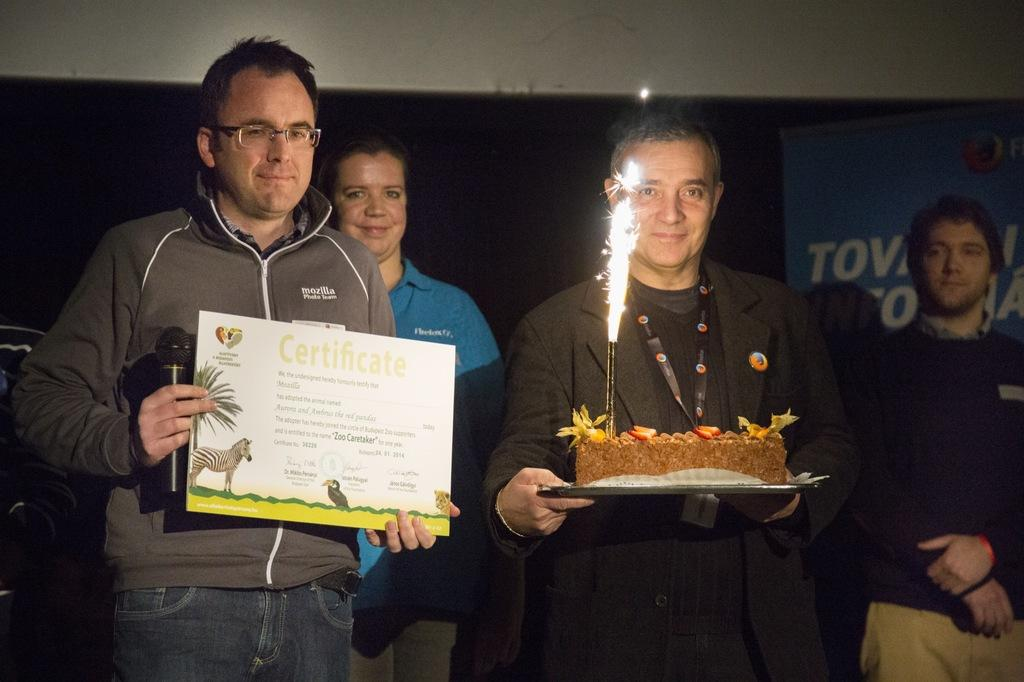What is happening in the image involving the people? There are people standing in the image, and a man is holding a cake with a firecracker candle. Can you describe the person standing beside the man holding the cake? The person beside the man holding the cake is holding a sheet and a microphone. What type of toothpaste is being used to decorate the yard in the image? There is no toothpaste or yard present in the image; it features people standing around a cake with a firecracker candle. What kind of feast is being prepared in the image? There is no feast being prepared in the image; it only shows people standing around a cake with a firecracker candle. 